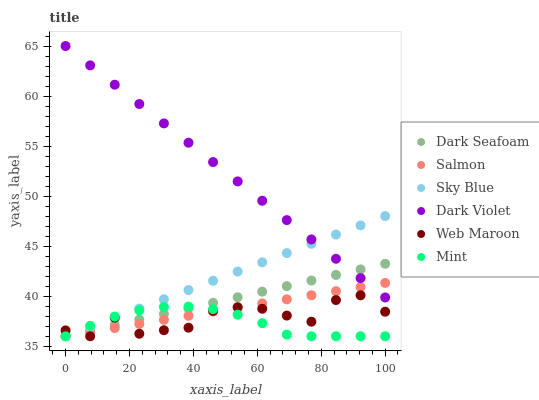Does Mint have the minimum area under the curve?
Answer yes or no. Yes. Does Dark Violet have the maximum area under the curve?
Answer yes or no. Yes. Does Web Maroon have the minimum area under the curve?
Answer yes or no. No. Does Web Maroon have the maximum area under the curve?
Answer yes or no. No. Is Dark Seafoam the smoothest?
Answer yes or no. Yes. Is Web Maroon the roughest?
Answer yes or no. Yes. Is Dark Violet the smoothest?
Answer yes or no. No. Is Dark Violet the roughest?
Answer yes or no. No. Does Salmon have the lowest value?
Answer yes or no. Yes. Does Dark Violet have the lowest value?
Answer yes or no. No. Does Dark Violet have the highest value?
Answer yes or no. Yes. Does Web Maroon have the highest value?
Answer yes or no. No. Is Mint less than Dark Violet?
Answer yes or no. Yes. Is Dark Violet greater than Web Maroon?
Answer yes or no. Yes. Does Salmon intersect Dark Violet?
Answer yes or no. Yes. Is Salmon less than Dark Violet?
Answer yes or no. No. Is Salmon greater than Dark Violet?
Answer yes or no. No. Does Mint intersect Dark Violet?
Answer yes or no. No. 